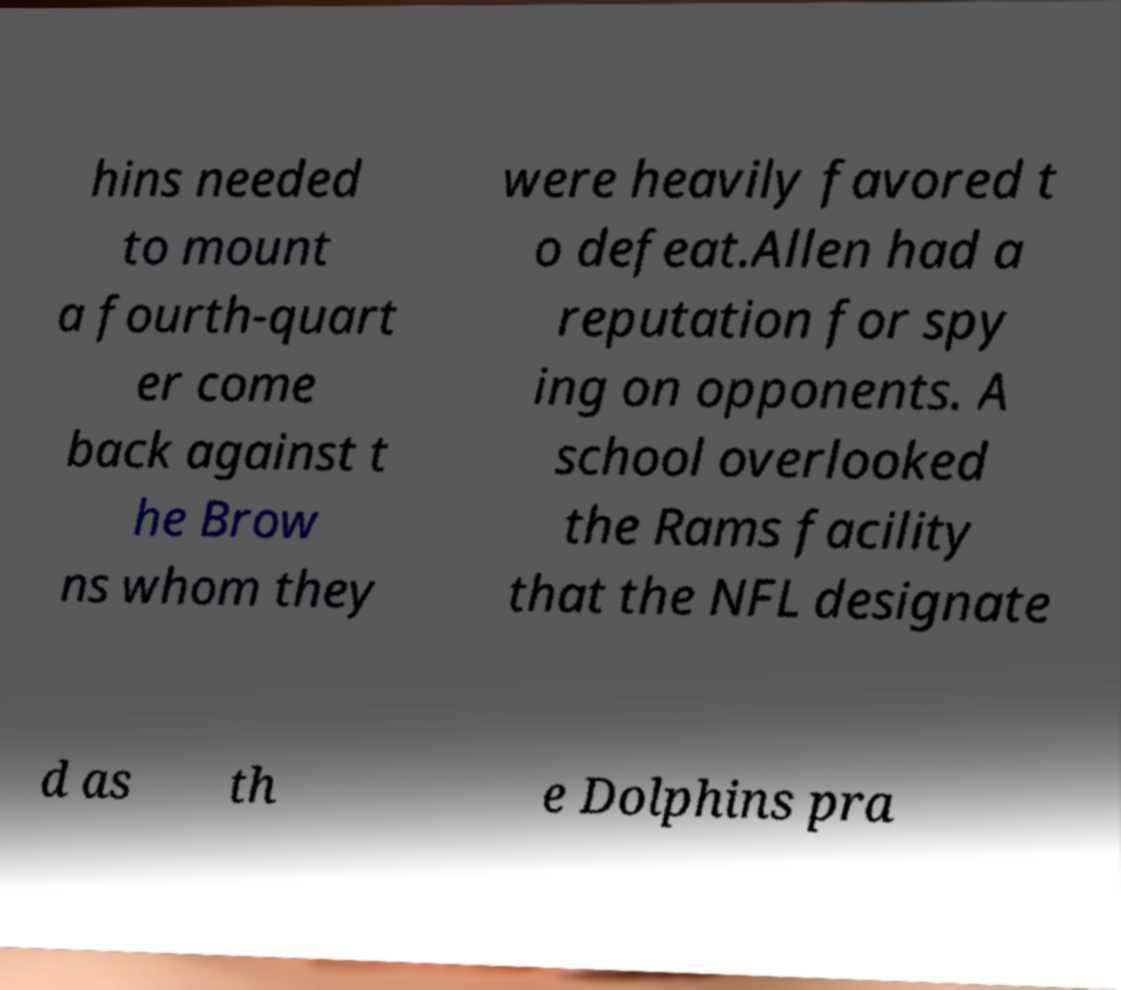What messages or text are displayed in this image? I need them in a readable, typed format. hins needed to mount a fourth-quart er come back against t he Brow ns whom they were heavily favored t o defeat.Allen had a reputation for spy ing on opponents. A school overlooked the Rams facility that the NFL designate d as th e Dolphins pra 